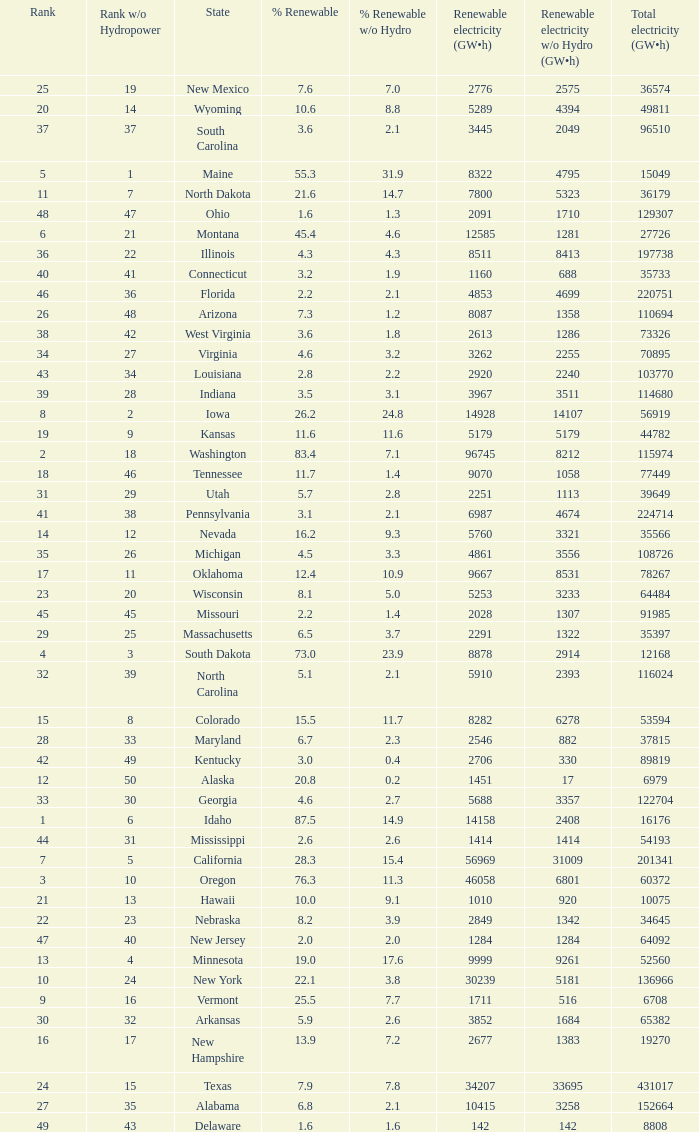When renewable electricity is 5760 (gw×h) what is the minimum amount of renewable elecrrixity without hydrogen power? 3321.0. 